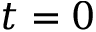Convert formula to latex. <formula><loc_0><loc_0><loc_500><loc_500>t = 0</formula> 